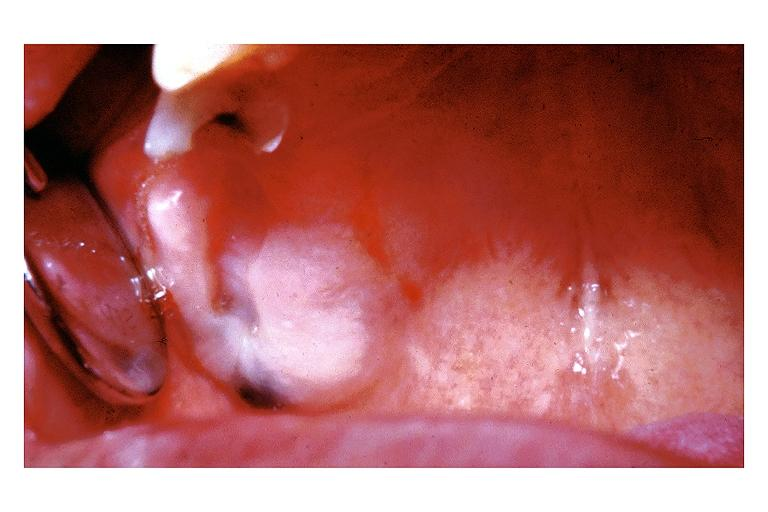what does this image show?
Answer the question using a single word or phrase. Amalgam tattoo 